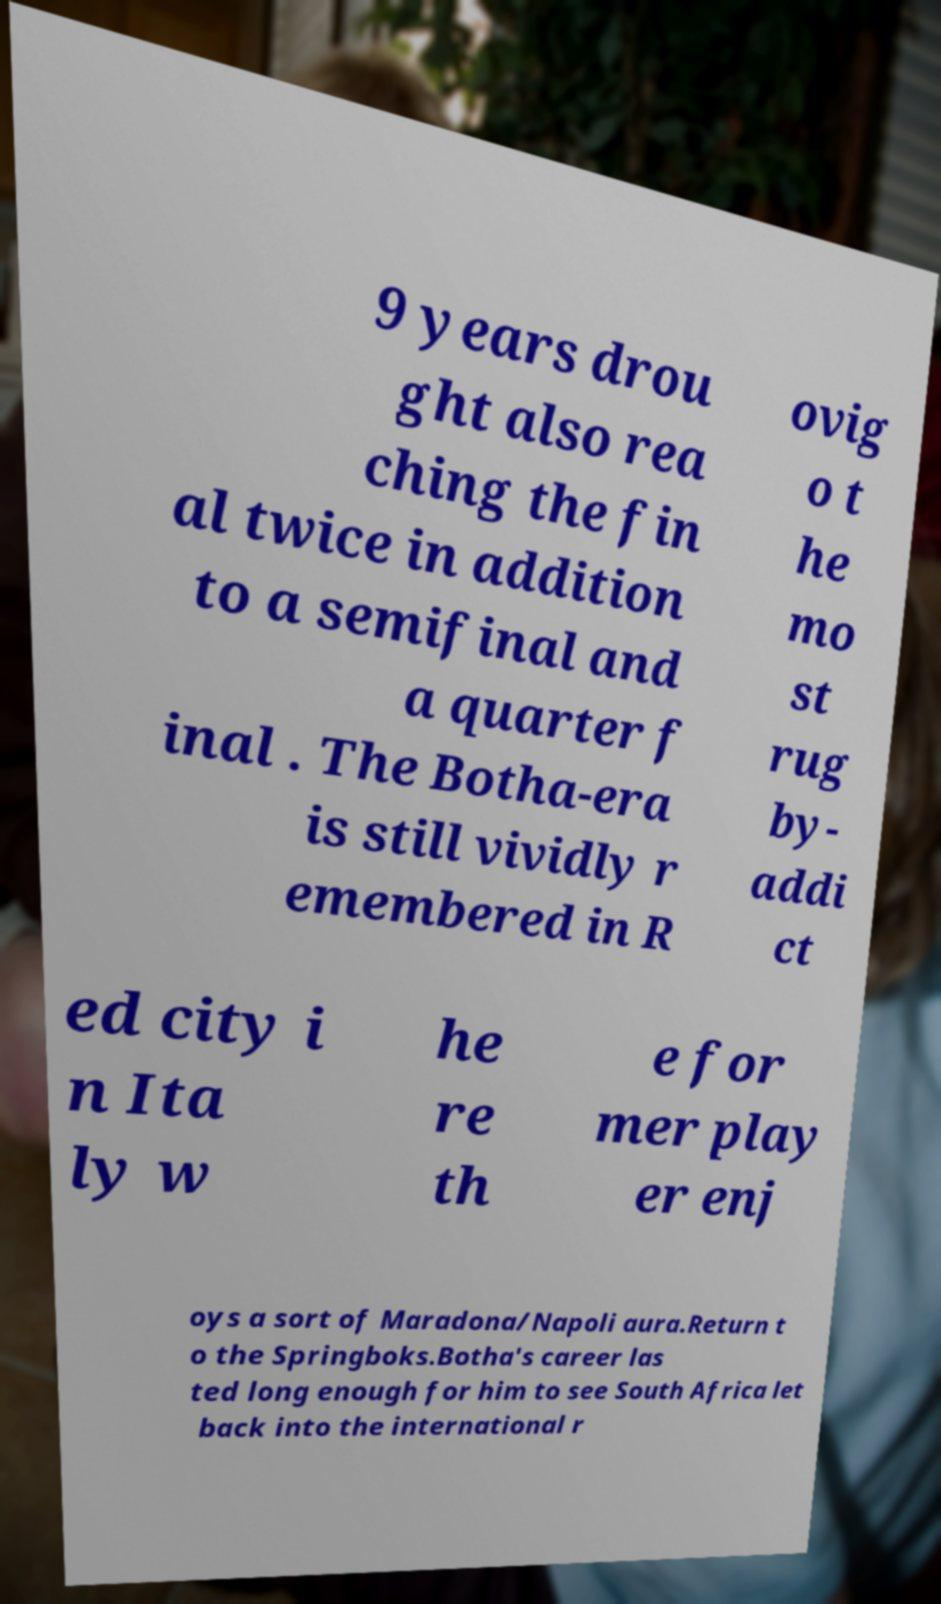Please read and relay the text visible in this image. What does it say? 9 years drou ght also rea ching the fin al twice in addition to a semifinal and a quarter f inal . The Botha-era is still vividly r emembered in R ovig o t he mo st rug by- addi ct ed city i n Ita ly w he re th e for mer play er enj oys a sort of Maradona/Napoli aura.Return t o the Springboks.Botha's career las ted long enough for him to see South Africa let back into the international r 